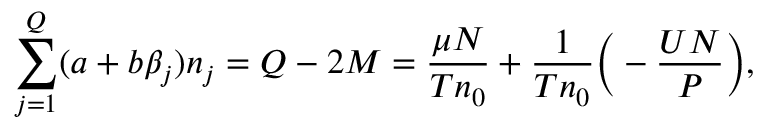<formula> <loc_0><loc_0><loc_500><loc_500>\sum _ { j = 1 } ^ { Q } ( a + b \beta _ { j } ) n _ { j } = Q - 2 M = \frac { \mu N } { T n _ { 0 } } + \frac { 1 } { T n _ { 0 } } \left ( - \frac { U N } { P } \right ) ,</formula> 